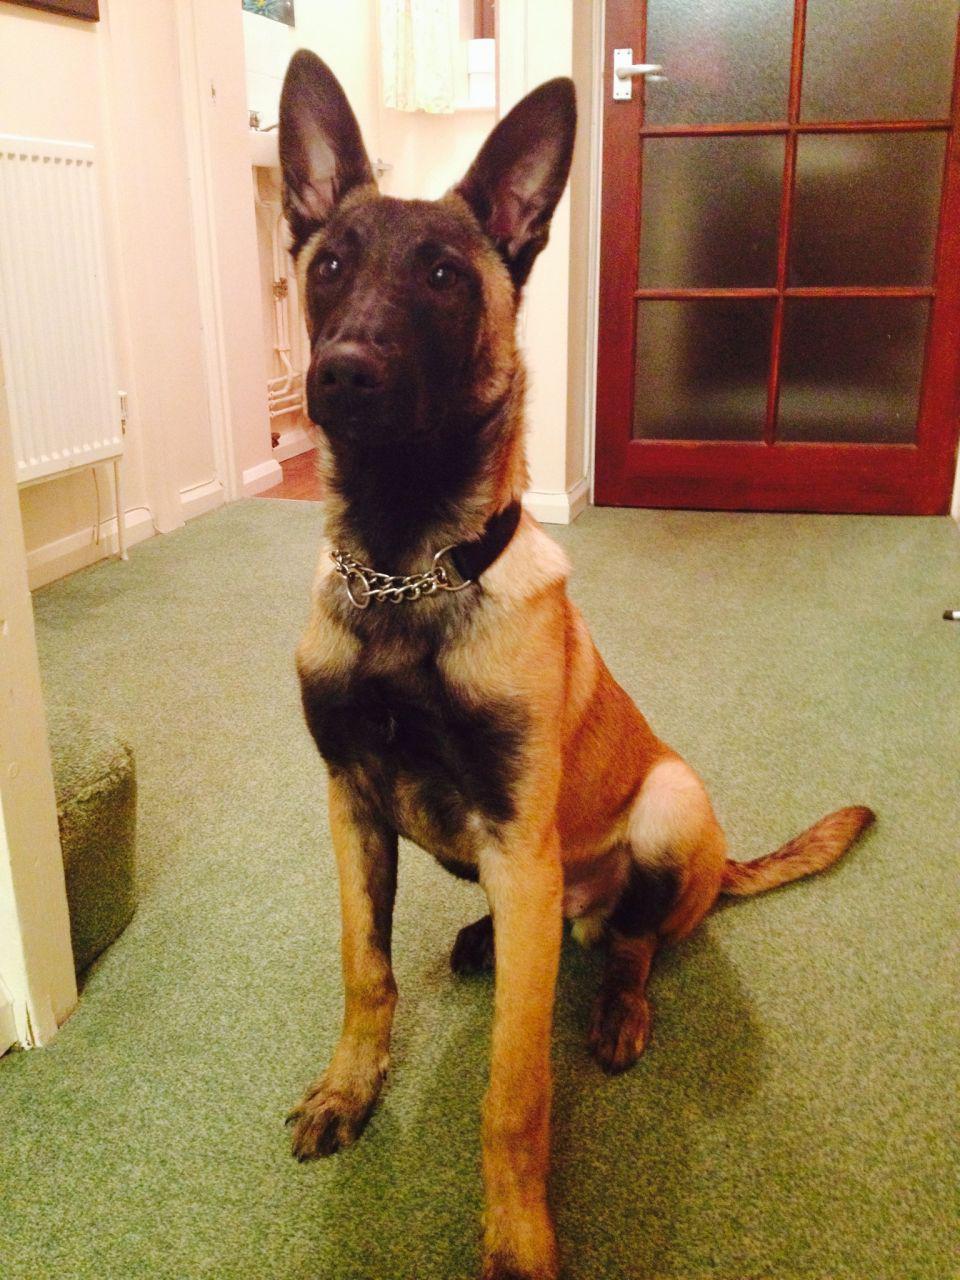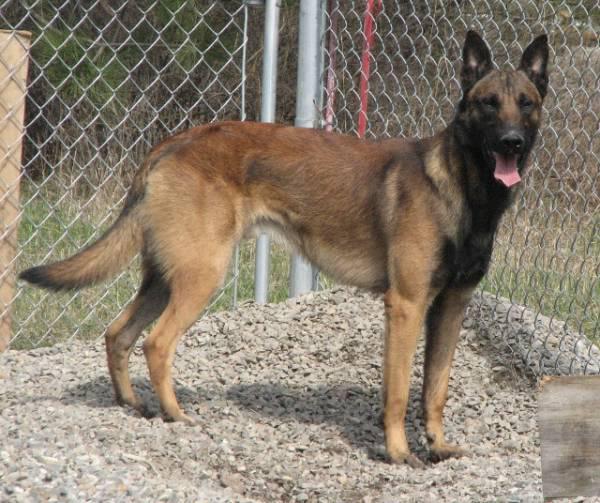The first image is the image on the left, the second image is the image on the right. For the images displayed, is the sentence "A large-eared dog's tongue is visible as it faces the camera." factually correct? Answer yes or no. Yes. The first image is the image on the left, the second image is the image on the right. For the images displayed, is the sentence "There is at least one dog sticking its tongue out." factually correct? Answer yes or no. Yes. 